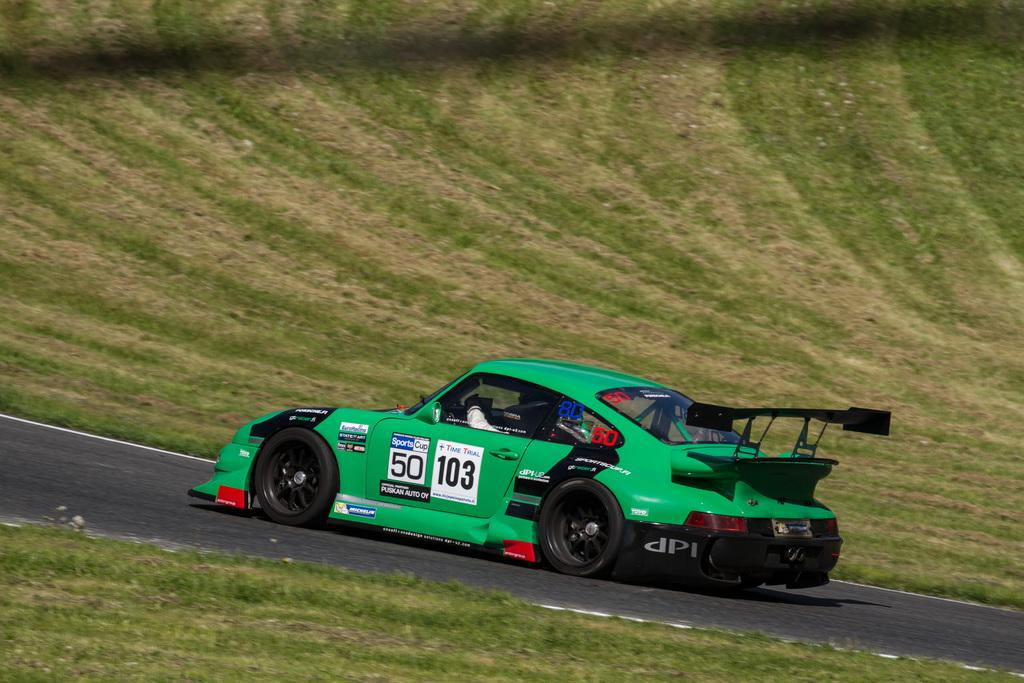What type of object is in the image? There is a vehicle in the image. What color is the vehicle? The vehicle is green in color. Where is the vehicle located? The vehicle is on the road. What can be seen in the background of the image? There is grass visible in the background of the image. What color is the grass? The grass is green in color. Can you tell me how many times your dad has copied the can in the image? There is no can or reference to your dad in the image, so it is not possible to answer that question. 